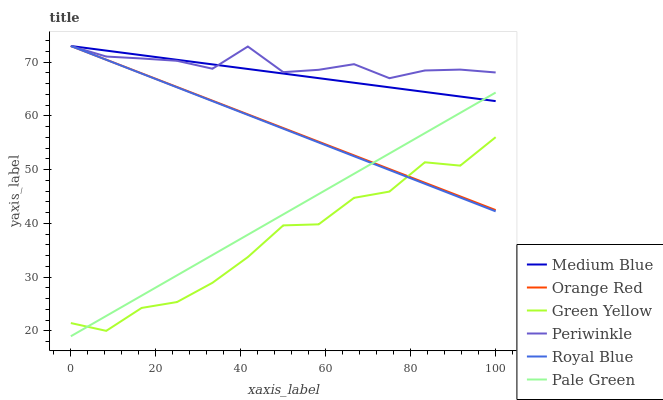Does Green Yellow have the minimum area under the curve?
Answer yes or no. Yes. Does Periwinkle have the maximum area under the curve?
Answer yes or no. Yes. Does Royal Blue have the minimum area under the curve?
Answer yes or no. No. Does Royal Blue have the maximum area under the curve?
Answer yes or no. No. Is Medium Blue the smoothest?
Answer yes or no. Yes. Is Green Yellow the roughest?
Answer yes or no. Yes. Is Royal Blue the smoothest?
Answer yes or no. No. Is Royal Blue the roughest?
Answer yes or no. No. Does Pale Green have the lowest value?
Answer yes or no. Yes. Does Royal Blue have the lowest value?
Answer yes or no. No. Does Orange Red have the highest value?
Answer yes or no. Yes. Does Pale Green have the highest value?
Answer yes or no. No. Is Green Yellow less than Medium Blue?
Answer yes or no. Yes. Is Medium Blue greater than Green Yellow?
Answer yes or no. Yes. Does Royal Blue intersect Periwinkle?
Answer yes or no. Yes. Is Royal Blue less than Periwinkle?
Answer yes or no. No. Is Royal Blue greater than Periwinkle?
Answer yes or no. No. Does Green Yellow intersect Medium Blue?
Answer yes or no. No. 